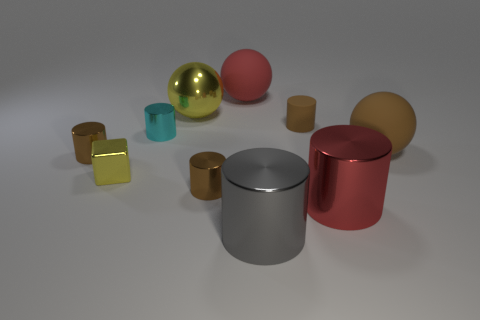There is a large ball that is the same color as the small cube; what material is it?
Offer a very short reply. Metal. Are there any matte objects that have the same shape as the cyan metal thing?
Offer a terse response. Yes. What number of brown metal things are there?
Your response must be concise. 2. Does the large red object on the left side of the gray metallic object have the same material as the yellow block?
Provide a short and direct response. No. Are there any gray metallic things that have the same size as the red cylinder?
Offer a very short reply. Yes. There is a small cyan object; is its shape the same as the metal object in front of the red shiny thing?
Make the answer very short. Yes. There is a rubber sphere in front of the yellow thing behind the tiny brown matte cylinder; are there any large objects to the left of it?
Provide a short and direct response. Yes. The yellow cube is what size?
Offer a very short reply. Small. How many other things are there of the same color as the tiny rubber cylinder?
Give a very brief answer. 3. Is the shape of the small shiny thing on the right side of the large metallic sphere the same as  the red rubber thing?
Your answer should be compact. No. 